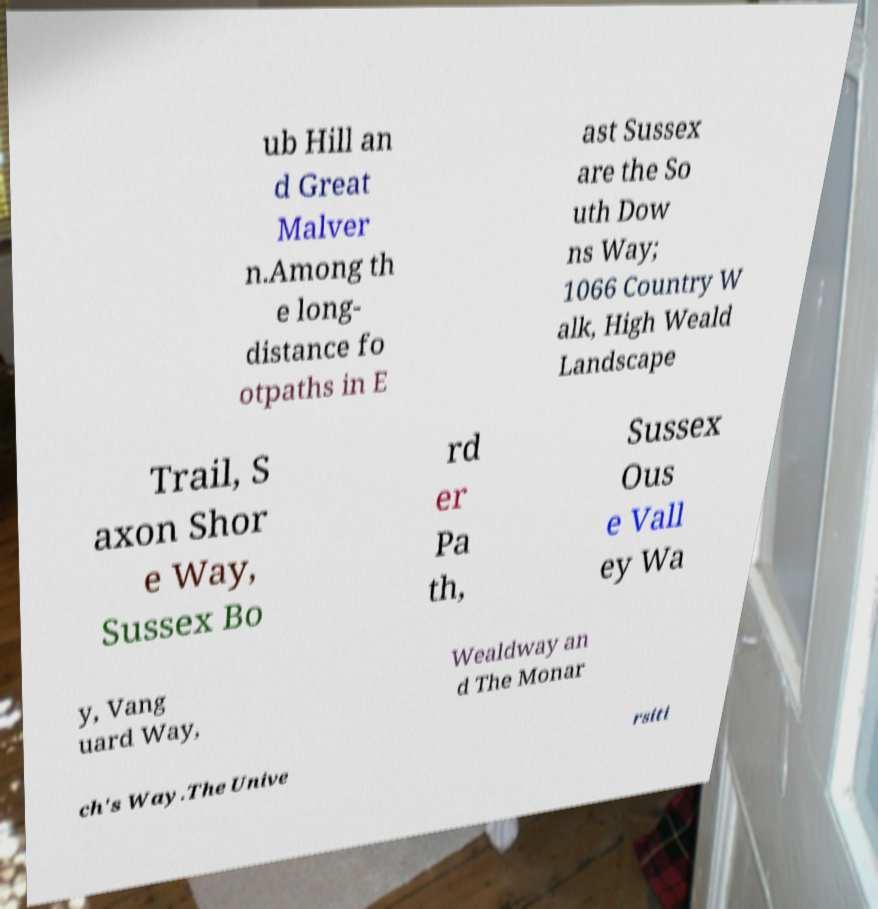What messages or text are displayed in this image? I need them in a readable, typed format. ub Hill an d Great Malver n.Among th e long- distance fo otpaths in E ast Sussex are the So uth Dow ns Way; 1066 Country W alk, High Weald Landscape Trail, S axon Shor e Way, Sussex Bo rd er Pa th, Sussex Ous e Vall ey Wa y, Vang uard Way, Wealdway an d The Monar ch's Way.The Unive rsiti 